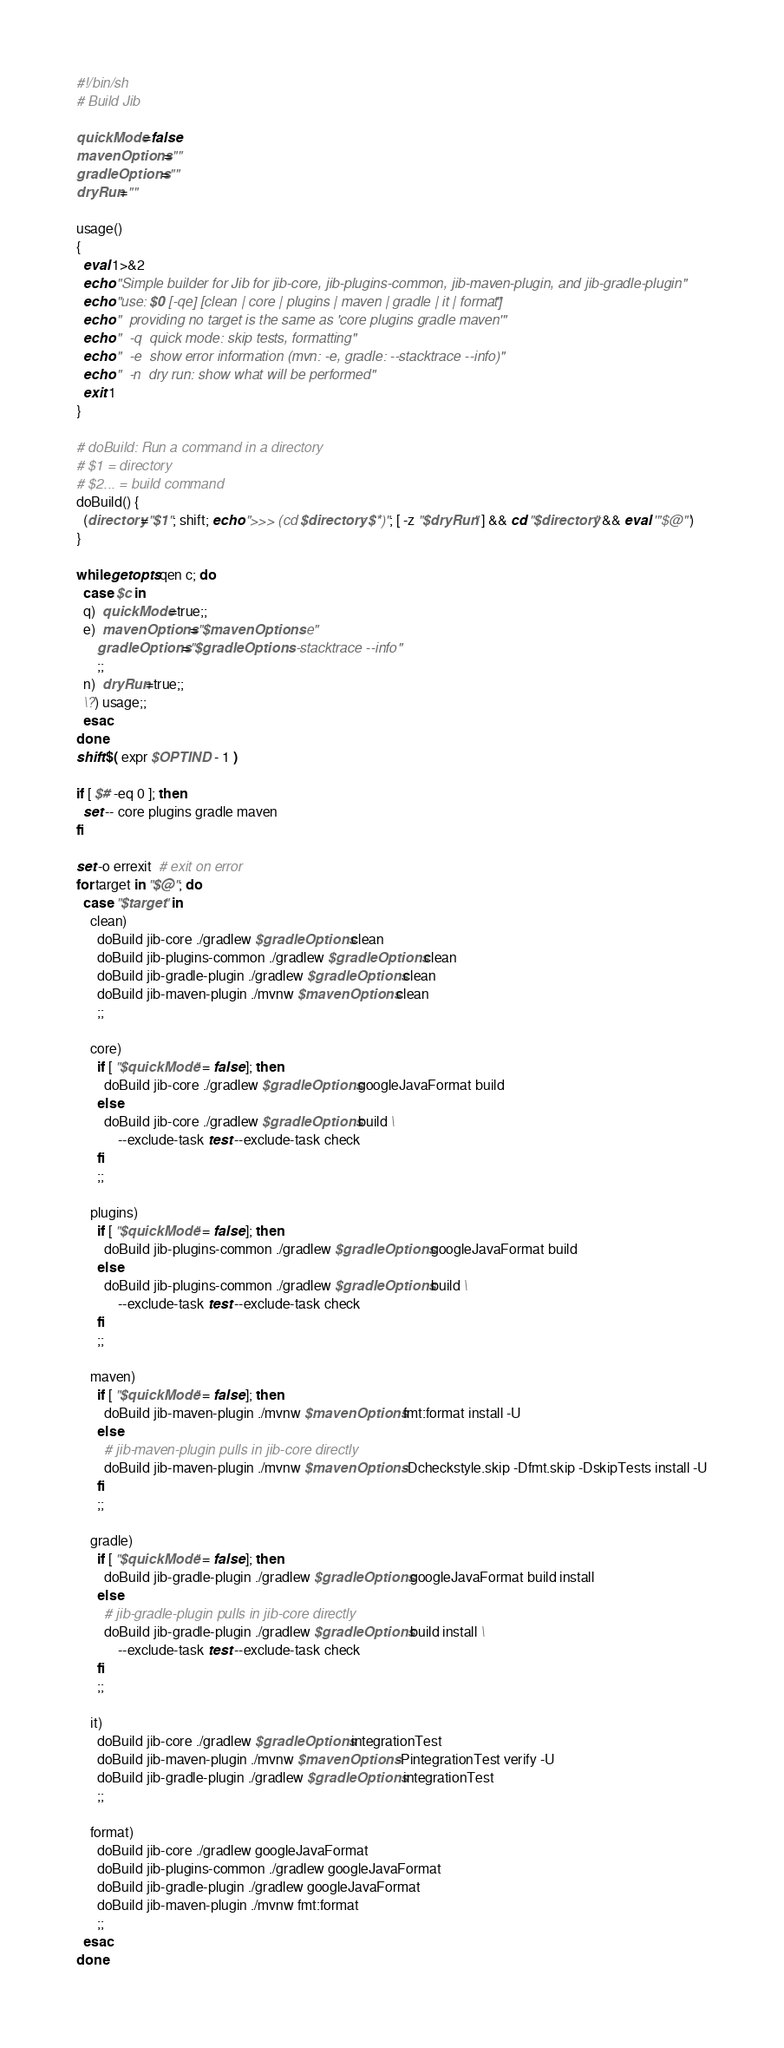Convert code to text. <code><loc_0><loc_0><loc_500><loc_500><_Bash_>#!/bin/sh
# Build Jib

quickMode=false
mavenOptions=""
gradleOptions=""
dryRun=""

usage()
{
  eval 1>&2
  echo "Simple builder for Jib for jib-core, jib-plugins-common, jib-maven-plugin, and jib-gradle-plugin"
  echo "use: $0 [-qe] [clean | core | plugins | maven | gradle | it | format]"
  echo "  providing no target is the same as 'core plugins gradle maven'"
  echo "  -q  quick mode: skip tests, formatting"
  echo "  -e  show error information (mvn: -e, gradle: --stacktrace --info)"
  echo "  -n  dry run: show what will be performed"
  exit 1
}

# doBuild: Run a command in a directory
# $1 = directory
# $2... = build command
doBuild() {
  (directory="$1"; shift; echo ">>> (cd $directory; $*)"; [ -z "$dryRun" ] && cd "$directory" && eval '"$@"')
}

while getopts qen c; do
  case $c in
  q)  quickMode=true;;
  e)  mavenOptions="$mavenOptions -e"
      gradleOptions="$gradleOptions --stacktrace --info"
      ;;
  n)  dryRun=true;;
  \?) usage;;
  esac
done
shift $( expr $OPTIND - 1 )

if [ $# -eq 0 ]; then
  set -- core plugins gradle maven
fi

set -o errexit  # exit on error
for target in "$@"; do
  case "$target" in
    clean)
      doBuild jib-core ./gradlew $gradleOptions clean
      doBuild jib-plugins-common ./gradlew $gradleOptions clean
      doBuild jib-gradle-plugin ./gradlew $gradleOptions clean
      doBuild jib-maven-plugin ./mvnw $mavenOptions clean
      ;;

    core)
      if [ "$quickMode" = false ]; then
        doBuild jib-core ./gradlew $gradleOptions googleJavaFormat build
      else
        doBuild jib-core ./gradlew $gradleOptions build \
            --exclude-task test --exclude-task check
      fi
      ;;

    plugins)
      if [ "$quickMode" = false ]; then
        doBuild jib-plugins-common ./gradlew $gradleOptions googleJavaFormat build
      else
        doBuild jib-plugins-common ./gradlew $gradleOptions build \
            --exclude-task test --exclude-task check
      fi
      ;;

    maven)
      if [ "$quickMode" = false ]; then
        doBuild jib-maven-plugin ./mvnw $mavenOptions fmt:format install -U
      else
        # jib-maven-plugin pulls in jib-core directly
        doBuild jib-maven-plugin ./mvnw $mavenOptions -Dcheckstyle.skip -Dfmt.skip -DskipTests install -U
      fi
      ;;

    gradle)
      if [ "$quickMode" = false ]; then
        doBuild jib-gradle-plugin ./gradlew $gradleOptions googleJavaFormat build install
      else
        # jib-gradle-plugin pulls in jib-core directly
        doBuild jib-gradle-plugin ./gradlew $gradleOptions build install \
            --exclude-task test --exclude-task check
      fi
      ;;

    it)
      doBuild jib-core ./gradlew $gradleOptions integrationTest
      doBuild jib-maven-plugin ./mvnw $mavenOptions -PintegrationTest verify -U
      doBuild jib-gradle-plugin ./gradlew $gradleOptions integrationTest
      ;;

    format)
      doBuild jib-core ./gradlew googleJavaFormat
      doBuild jib-plugins-common ./gradlew googleJavaFormat
      doBuild jib-gradle-plugin ./gradlew googleJavaFormat
      doBuild jib-maven-plugin ./mvnw fmt:format
      ;;
  esac
done
</code> 